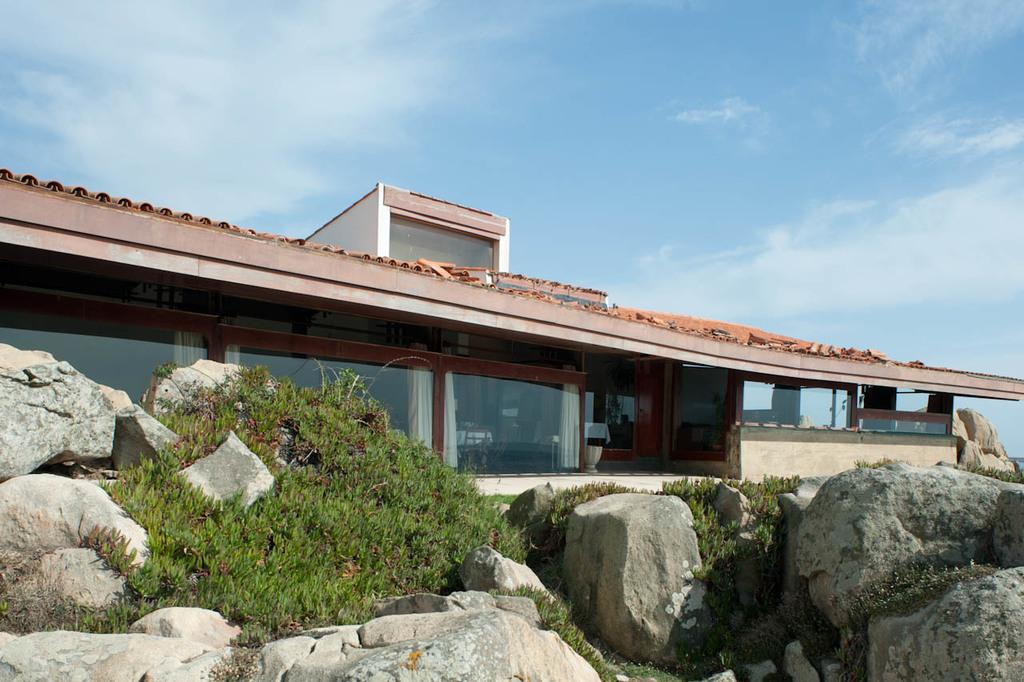What is in the foreground of the image? There are stones and grass in the foreground of the image. What can be seen in the background of the image? There is a building and a glass object with curtains in the background of the image. What is visible at the top of the image? The sky is visible at the top of the image, and there is a cloud visible in the sky. Can you describe the impulse that caused the development of the kiss in the image? There is no kiss or impulse present in the image; it features stones, grass, a building, a glass object with curtains, and a cloud in the sky. 